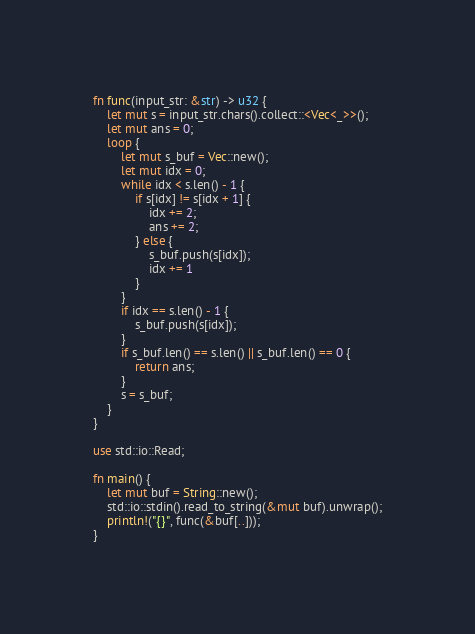Convert code to text. <code><loc_0><loc_0><loc_500><loc_500><_Rust_>
fn func(input_str: &str) -> u32 {
    let mut s = input_str.chars().collect::<Vec<_>>();
    let mut ans = 0;
    loop {
        let mut s_buf = Vec::new();
        let mut idx = 0;
        while idx < s.len() - 1 {
            if s[idx] != s[idx + 1] {
                idx += 2;
                ans += 2;
            } else {
                s_buf.push(s[idx]);
                idx += 1
            }
        }
        if idx == s.len() - 1 {
            s_buf.push(s[idx]);
        }
        if s_buf.len() == s.len() || s_buf.len() == 0 {
            return ans;
        }
        s = s_buf;
    }
}

use std::io::Read;

fn main() {
    let mut buf = String::new();
    std::io::stdin().read_to_string(&mut buf).unwrap();
    println!("{}", func(&buf[..]));
}
</code> 